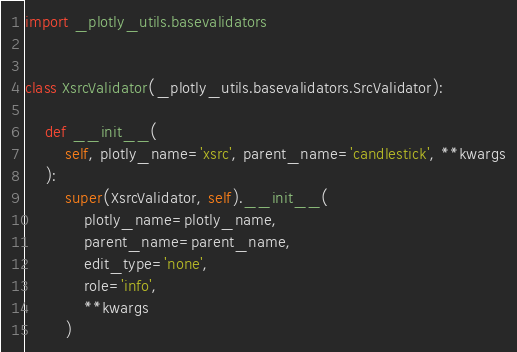<code> <loc_0><loc_0><loc_500><loc_500><_Python_>import _plotly_utils.basevalidators


class XsrcValidator(_plotly_utils.basevalidators.SrcValidator):

    def __init__(
        self, plotly_name='xsrc', parent_name='candlestick', **kwargs
    ):
        super(XsrcValidator, self).__init__(
            plotly_name=plotly_name,
            parent_name=parent_name,
            edit_type='none',
            role='info',
            **kwargs
        )
</code> 